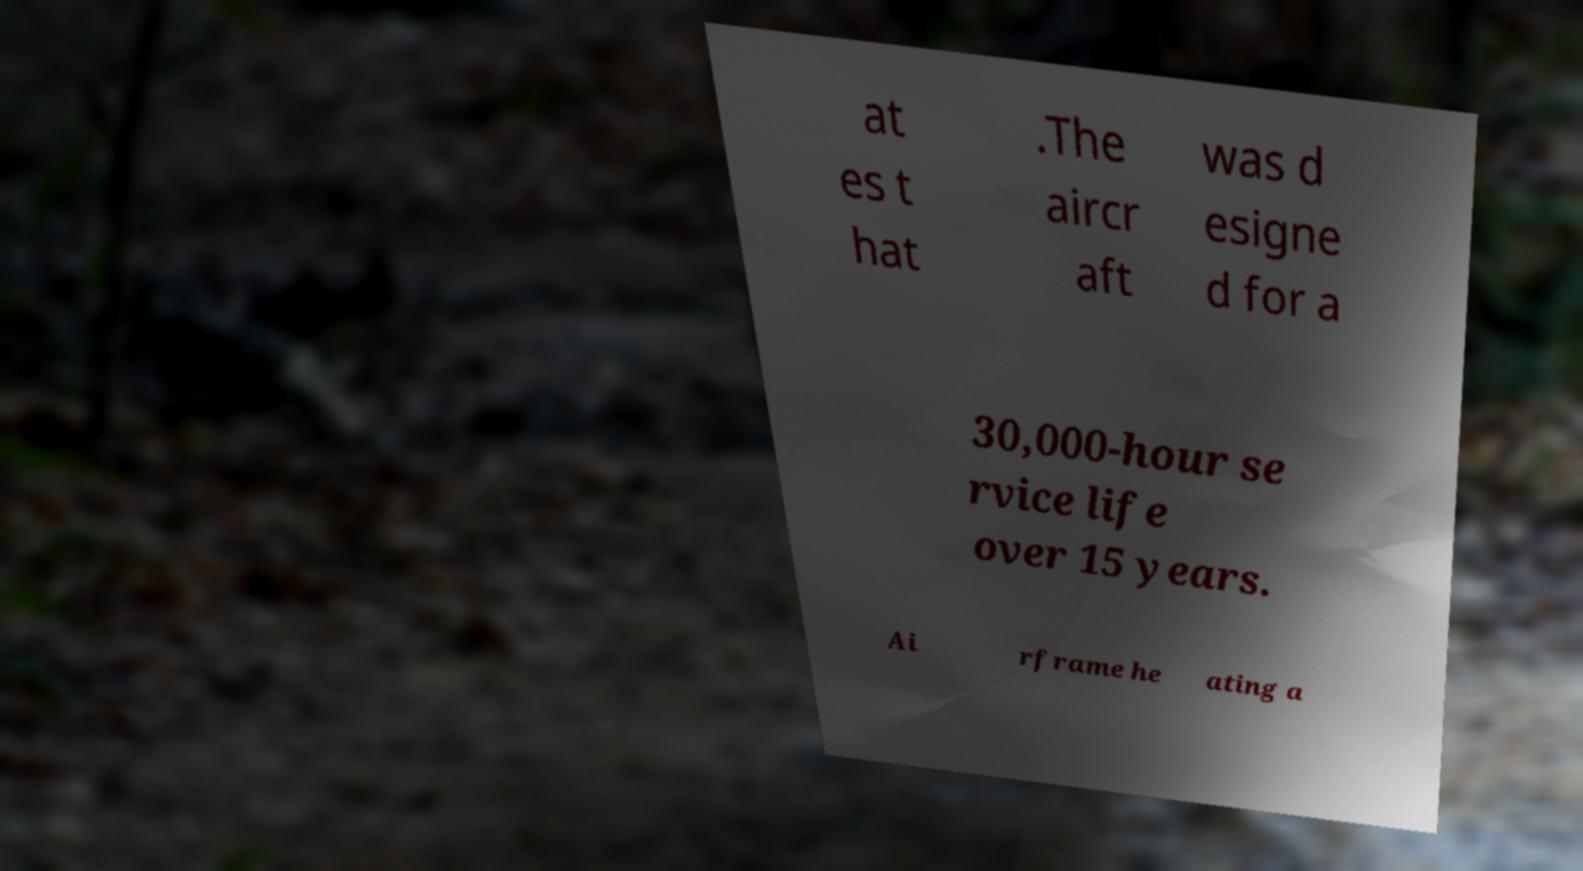Please read and relay the text visible in this image. What does it say? at es t hat .The aircr aft was d esigne d for a 30,000-hour se rvice life over 15 years. Ai rframe he ating a 